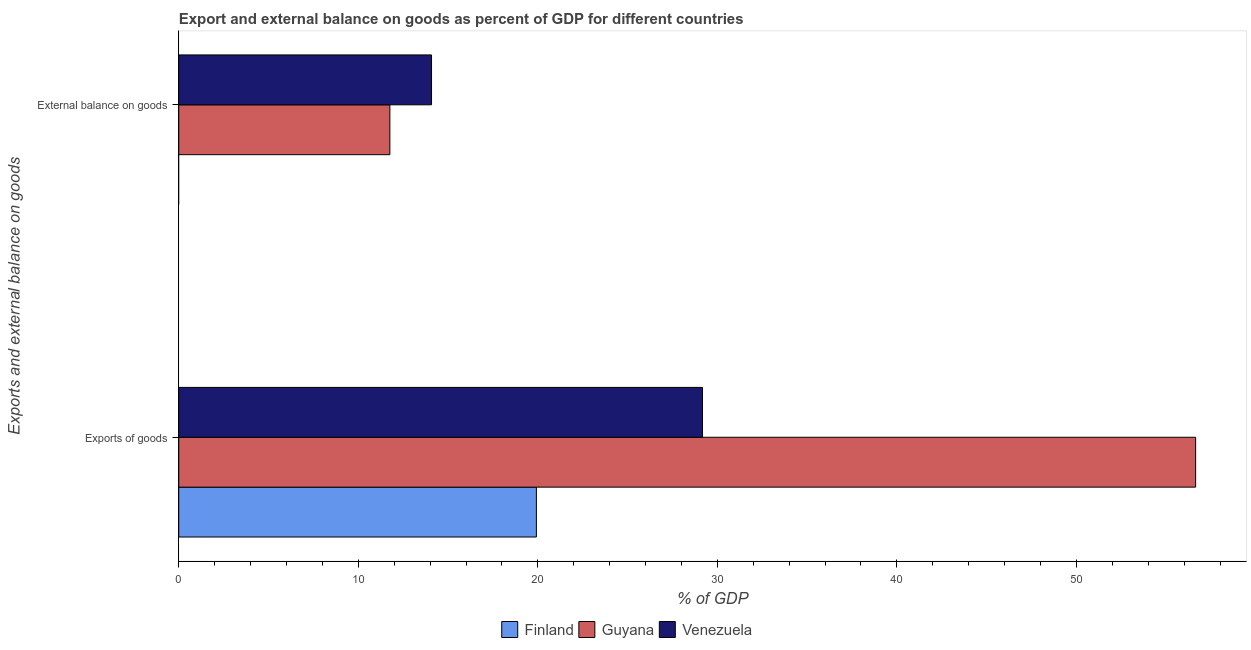How many different coloured bars are there?
Keep it short and to the point. 3. Are the number of bars per tick equal to the number of legend labels?
Offer a very short reply. No. Are the number of bars on each tick of the Y-axis equal?
Ensure brevity in your answer.  No. How many bars are there on the 1st tick from the top?
Keep it short and to the point. 2. How many bars are there on the 2nd tick from the bottom?
Offer a terse response. 2. What is the label of the 1st group of bars from the top?
Your answer should be very brief. External balance on goods. What is the external balance on goods as percentage of gdp in Guyana?
Your answer should be compact. 11.76. Across all countries, what is the maximum external balance on goods as percentage of gdp?
Your answer should be compact. 14.08. Across all countries, what is the minimum export of goods as percentage of gdp?
Keep it short and to the point. 19.92. In which country was the export of goods as percentage of gdp maximum?
Keep it short and to the point. Guyana. What is the total export of goods as percentage of gdp in the graph?
Provide a short and direct response. 105.73. What is the difference between the export of goods as percentage of gdp in Venezuela and that in Guyana?
Offer a terse response. -27.47. What is the difference between the export of goods as percentage of gdp in Finland and the external balance on goods as percentage of gdp in Venezuela?
Keep it short and to the point. 5.84. What is the average export of goods as percentage of gdp per country?
Your answer should be very brief. 35.24. What is the difference between the external balance on goods as percentage of gdp and export of goods as percentage of gdp in Venezuela?
Your answer should be very brief. -15.09. What is the ratio of the export of goods as percentage of gdp in Finland to that in Guyana?
Keep it short and to the point. 0.35. Is the export of goods as percentage of gdp in Guyana less than that in Venezuela?
Your response must be concise. No. In how many countries, is the external balance on goods as percentage of gdp greater than the average external balance on goods as percentage of gdp taken over all countries?
Ensure brevity in your answer.  2. How many bars are there?
Your answer should be very brief. 5. Does the graph contain any zero values?
Your answer should be compact. Yes. Does the graph contain grids?
Make the answer very short. No. How many legend labels are there?
Your answer should be very brief. 3. How are the legend labels stacked?
Offer a very short reply. Horizontal. What is the title of the graph?
Your response must be concise. Export and external balance on goods as percent of GDP for different countries. What is the label or title of the X-axis?
Give a very brief answer. % of GDP. What is the label or title of the Y-axis?
Ensure brevity in your answer.  Exports and external balance on goods. What is the % of GDP of Finland in Exports of goods?
Provide a short and direct response. 19.92. What is the % of GDP in Guyana in Exports of goods?
Your answer should be very brief. 56.64. What is the % of GDP of Venezuela in Exports of goods?
Your response must be concise. 29.17. What is the % of GDP in Finland in External balance on goods?
Your response must be concise. 0. What is the % of GDP of Guyana in External balance on goods?
Give a very brief answer. 11.76. What is the % of GDP in Venezuela in External balance on goods?
Your response must be concise. 14.08. Across all Exports and external balance on goods, what is the maximum % of GDP in Finland?
Provide a short and direct response. 19.92. Across all Exports and external balance on goods, what is the maximum % of GDP in Guyana?
Make the answer very short. 56.64. Across all Exports and external balance on goods, what is the maximum % of GDP in Venezuela?
Make the answer very short. 29.17. Across all Exports and external balance on goods, what is the minimum % of GDP of Finland?
Give a very brief answer. 0. Across all Exports and external balance on goods, what is the minimum % of GDP of Guyana?
Offer a terse response. 11.76. Across all Exports and external balance on goods, what is the minimum % of GDP of Venezuela?
Your answer should be very brief. 14.08. What is the total % of GDP in Finland in the graph?
Offer a very short reply. 19.92. What is the total % of GDP in Guyana in the graph?
Provide a succinct answer. 68.4. What is the total % of GDP of Venezuela in the graph?
Your answer should be very brief. 43.25. What is the difference between the % of GDP in Guyana in Exports of goods and that in External balance on goods?
Provide a succinct answer. 44.88. What is the difference between the % of GDP of Venezuela in Exports of goods and that in External balance on goods?
Keep it short and to the point. 15.09. What is the difference between the % of GDP of Finland in Exports of goods and the % of GDP of Guyana in External balance on goods?
Offer a very short reply. 8.16. What is the difference between the % of GDP in Finland in Exports of goods and the % of GDP in Venezuela in External balance on goods?
Make the answer very short. 5.84. What is the difference between the % of GDP of Guyana in Exports of goods and the % of GDP of Venezuela in External balance on goods?
Ensure brevity in your answer.  42.56. What is the average % of GDP in Finland per Exports and external balance on goods?
Keep it short and to the point. 9.96. What is the average % of GDP in Guyana per Exports and external balance on goods?
Your answer should be very brief. 34.2. What is the average % of GDP of Venezuela per Exports and external balance on goods?
Make the answer very short. 21.62. What is the difference between the % of GDP in Finland and % of GDP in Guyana in Exports of goods?
Give a very brief answer. -36.72. What is the difference between the % of GDP of Finland and % of GDP of Venezuela in Exports of goods?
Your answer should be compact. -9.25. What is the difference between the % of GDP in Guyana and % of GDP in Venezuela in Exports of goods?
Give a very brief answer. 27.47. What is the difference between the % of GDP in Guyana and % of GDP in Venezuela in External balance on goods?
Your response must be concise. -2.32. What is the ratio of the % of GDP in Guyana in Exports of goods to that in External balance on goods?
Provide a short and direct response. 4.82. What is the ratio of the % of GDP in Venezuela in Exports of goods to that in External balance on goods?
Your response must be concise. 2.07. What is the difference between the highest and the second highest % of GDP in Guyana?
Your answer should be compact. 44.88. What is the difference between the highest and the second highest % of GDP in Venezuela?
Your response must be concise. 15.09. What is the difference between the highest and the lowest % of GDP of Finland?
Provide a succinct answer. 19.92. What is the difference between the highest and the lowest % of GDP of Guyana?
Ensure brevity in your answer.  44.88. What is the difference between the highest and the lowest % of GDP of Venezuela?
Keep it short and to the point. 15.09. 